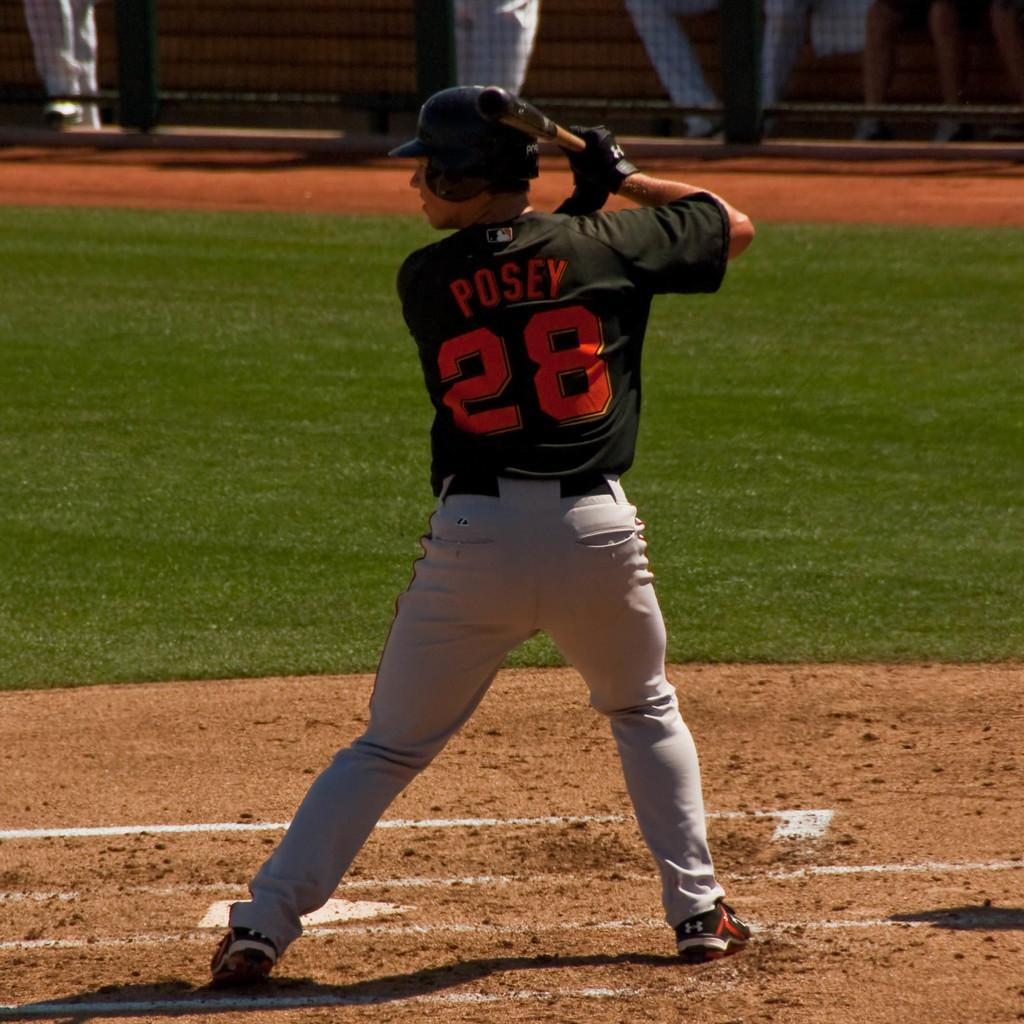<image>
Present a compact description of the photo's key features. Posey is at the plate getting ready to bat. 